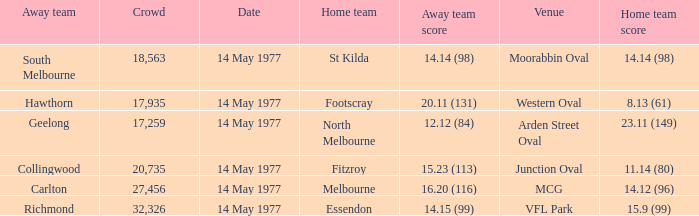I want to know the home team score of the away team of richmond that has a crowd more than 20,735 15.9 (99). 